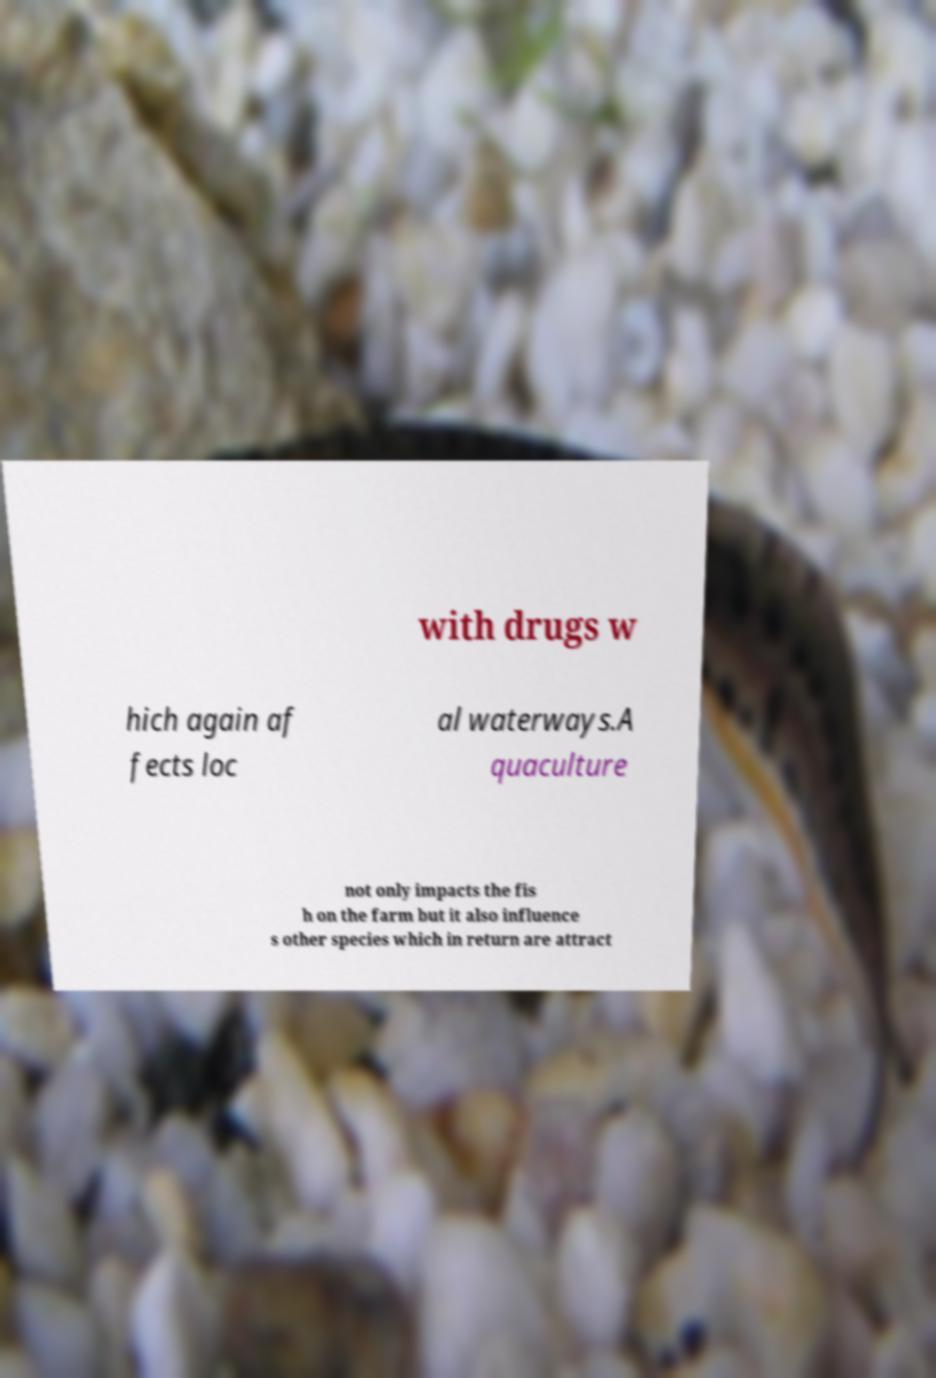Could you assist in decoding the text presented in this image and type it out clearly? with drugs w hich again af fects loc al waterways.A quaculture not only impacts the fis h on the farm but it also influence s other species which in return are attract 